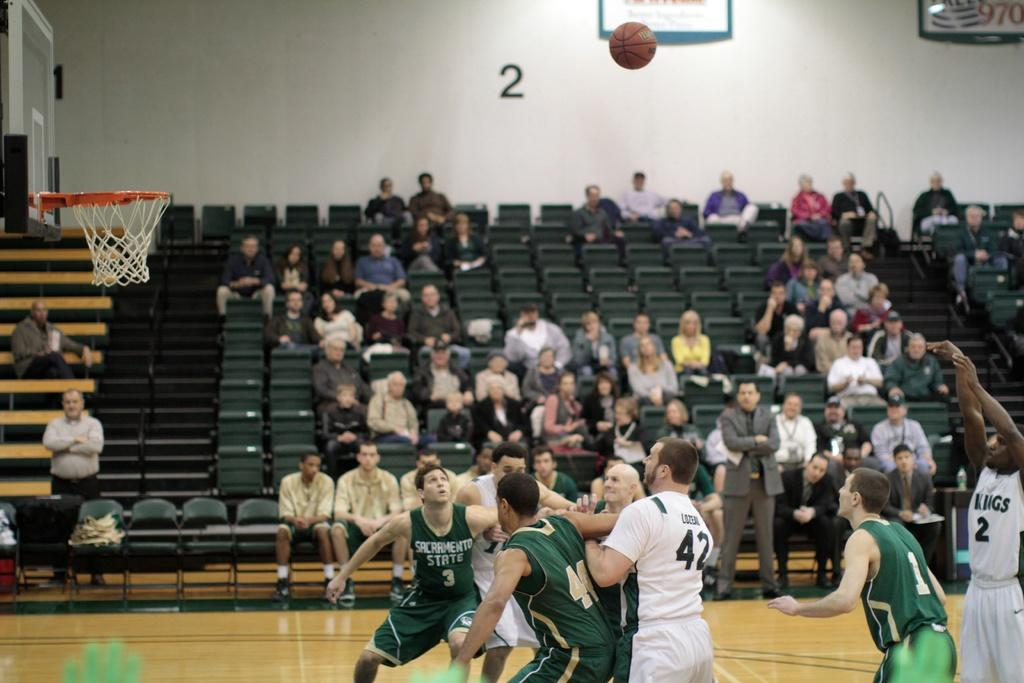<image>
Present a compact description of the photo's key features. Player number 2 for the KINGS makes a shot from the three pointer line 